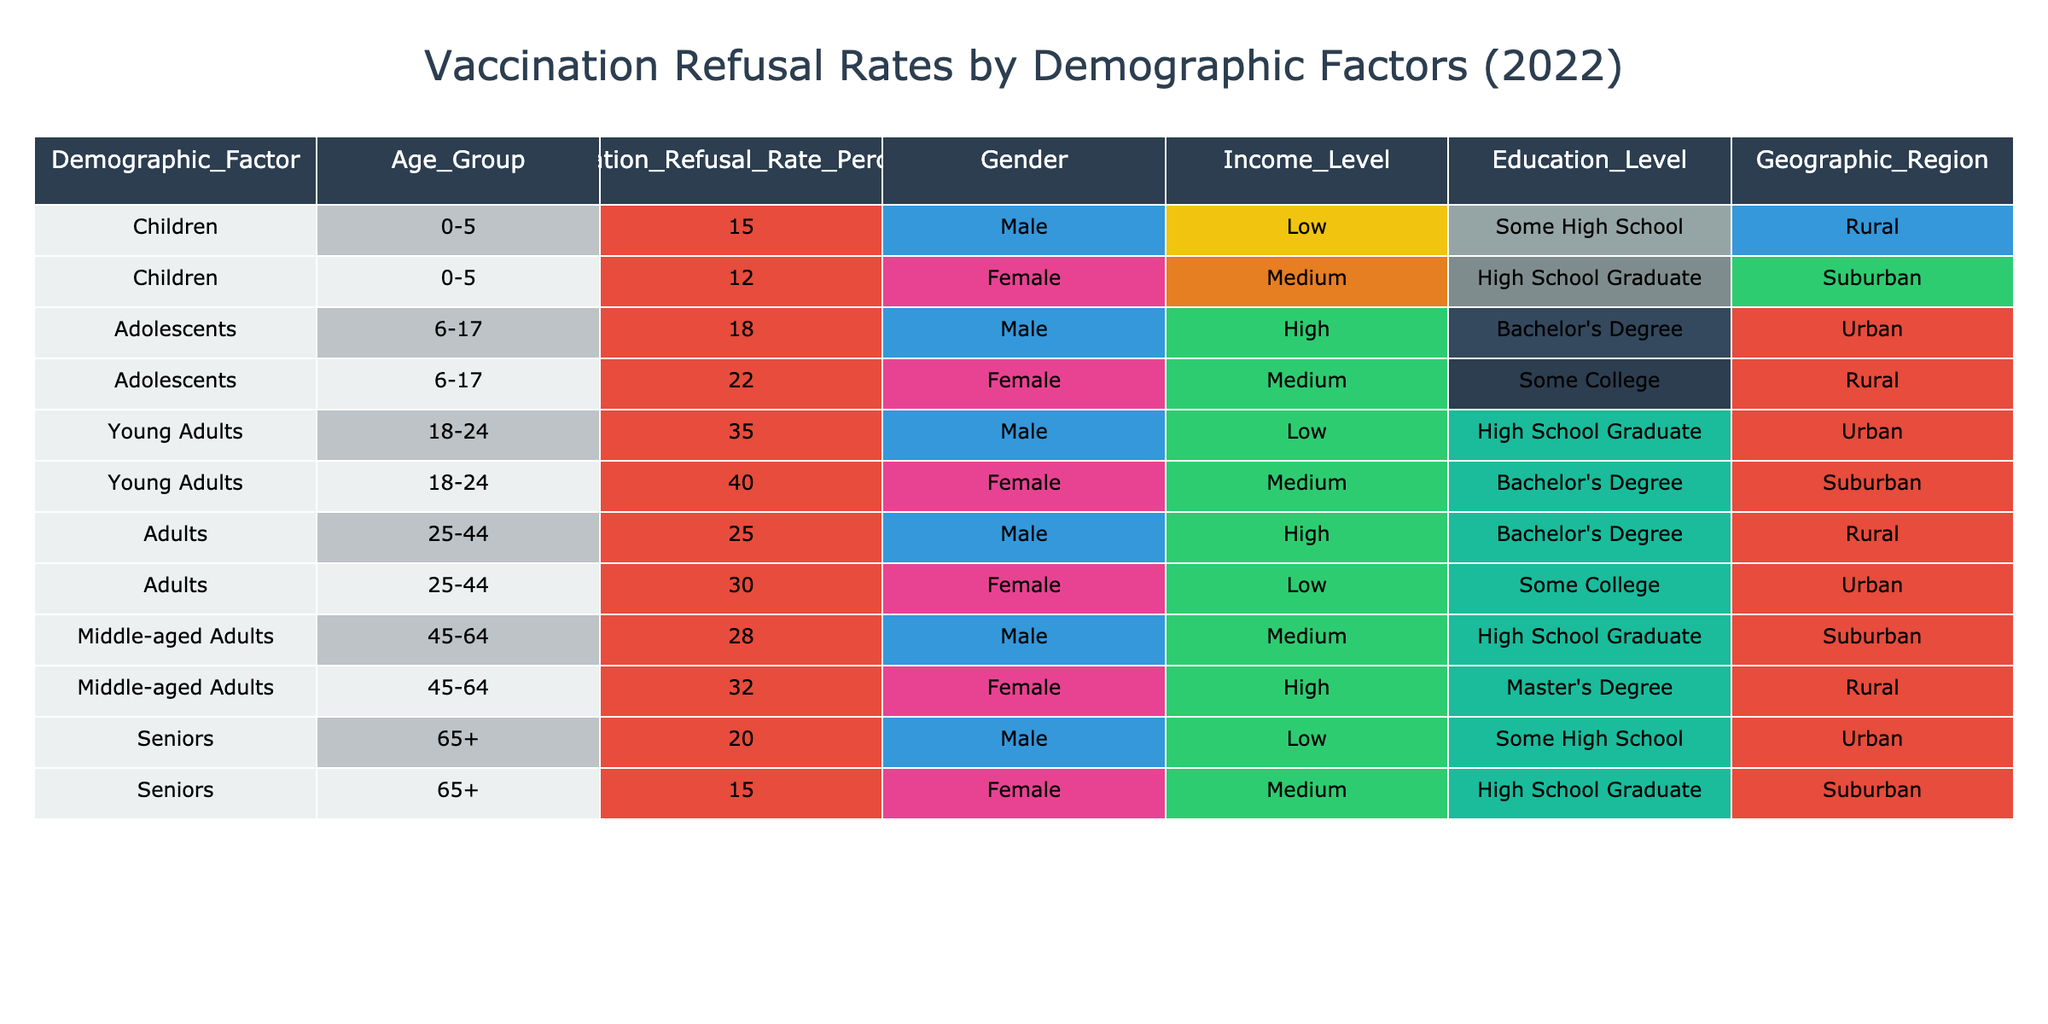What is the vaccination refusal rate for males aged 18-24? The table indicates that the vaccination refusal rate for males in the age group of 18-24 is 35%.
Answer: 35% What is the vaccination refusal rate for females in the age group of 45-64? According to the table, the rate for females aged 45-64 is 32%.
Answer: 32% Which income level has the highest vaccination refusal rate among young adults? Looking at the young adults (ages 18-24), males from the low-income level have a refusal rate of 35%, and females from the medium-income level have a refusal rate of 40%. Thus, the highest rate is 40% for females.
Answer: 40% Who has a higher vaccination refusal rate, adolescents or young adults? The highest refusal rate among adolescents (ages 6-17) is 22% (for females), while the lowest for young adults (ages 18-24) is 35%. Therefore, young adults have a higher refusal rate.
Answer: Young adults Is the refusal rate for seniors higher than that for children? The refusal rates for seniors is 20% for males and 15% for females, while for children, it's 15% for males and 12% for females. Since both percentages are lower for children, the refusal rate for seniors is not higher.
Answer: No What is the average vaccination refusal rate for females across all age groups? The refusal rates for females by age groups are: 12% (children) + 22% (adolescents) + 40% (young adults) + 30% (adults) + 32% (middle-aged adults) + 15% (seniors). The total is 151%, and dividing by 6 age groups gives us an average of approximately 25.17%.
Answer: 25.17% In which geographic region do middle-aged adults have the lowest vaccination refusal rate? For middle-aged adults (ages 45-64), the refusal rates are 32% for females in the rural region and 28% for males in the medium-income suburban region. Thus, the suburban region has the lowest refusal rate for this demographic.
Answer: Suburban How many demographic categories have a refusal rate of 30% or more? The demographic categories with refusal rates of 30% or more are: young adults (both males and females), adolescents (females), and middle-aged adults (females). Therefore, there are four categories (including the males in middle-aged).
Answer: 4 What is the total vaccination refusal rate for children? The table shows that children aged 0-5 have refusal rates of 15% for males and 12% for females. Adding these gives us 15% + 12% = 27%.
Answer: 27% 